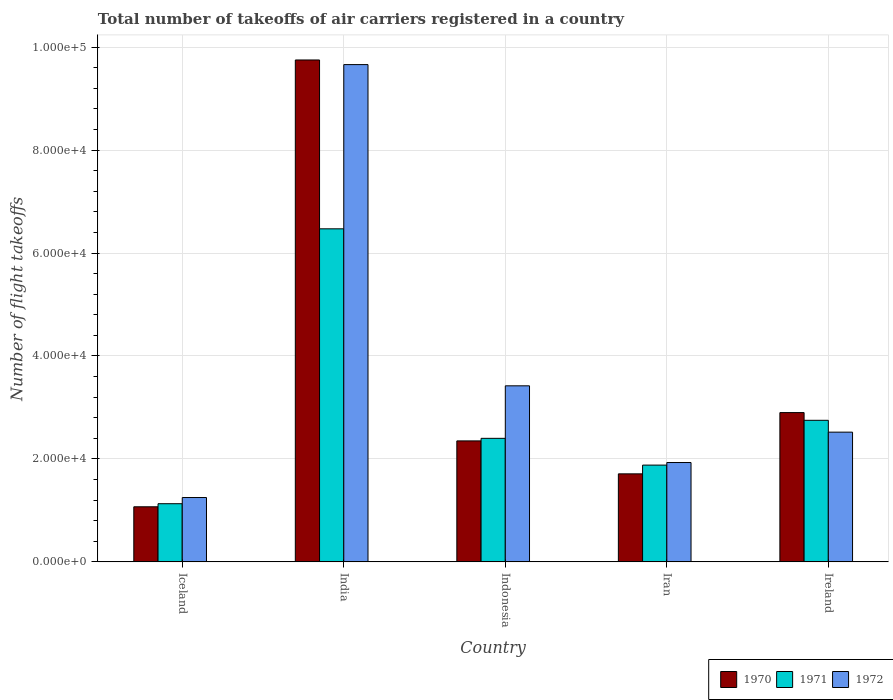How many different coloured bars are there?
Your answer should be very brief. 3. How many groups of bars are there?
Your response must be concise. 5. Are the number of bars per tick equal to the number of legend labels?
Give a very brief answer. Yes. Are the number of bars on each tick of the X-axis equal?
Give a very brief answer. Yes. How many bars are there on the 1st tick from the right?
Offer a very short reply. 3. What is the total number of flight takeoffs in 1970 in Indonesia?
Your answer should be very brief. 2.35e+04. Across all countries, what is the maximum total number of flight takeoffs in 1970?
Make the answer very short. 9.75e+04. Across all countries, what is the minimum total number of flight takeoffs in 1971?
Give a very brief answer. 1.13e+04. In which country was the total number of flight takeoffs in 1970 maximum?
Your response must be concise. India. In which country was the total number of flight takeoffs in 1972 minimum?
Give a very brief answer. Iceland. What is the total total number of flight takeoffs in 1972 in the graph?
Keep it short and to the point. 1.88e+05. What is the difference between the total number of flight takeoffs in 1972 in Iceland and that in India?
Make the answer very short. -8.41e+04. What is the difference between the total number of flight takeoffs in 1970 in Iceland and the total number of flight takeoffs in 1972 in Indonesia?
Give a very brief answer. -2.35e+04. What is the average total number of flight takeoffs in 1972 per country?
Your answer should be very brief. 3.76e+04. What is the difference between the total number of flight takeoffs of/in 1970 and total number of flight takeoffs of/in 1972 in Ireland?
Keep it short and to the point. 3800. What is the ratio of the total number of flight takeoffs in 1971 in Iceland to that in Iran?
Your response must be concise. 0.6. Is the total number of flight takeoffs in 1972 in India less than that in Iran?
Provide a succinct answer. No. Is the difference between the total number of flight takeoffs in 1970 in Iceland and Iran greater than the difference between the total number of flight takeoffs in 1972 in Iceland and Iran?
Provide a short and direct response. Yes. What is the difference between the highest and the second highest total number of flight takeoffs in 1970?
Your answer should be very brief. 5500. What is the difference between the highest and the lowest total number of flight takeoffs in 1972?
Provide a succinct answer. 8.41e+04. Is the sum of the total number of flight takeoffs in 1972 in India and Ireland greater than the maximum total number of flight takeoffs in 1971 across all countries?
Offer a terse response. Yes. What does the 2nd bar from the right in Iceland represents?
Make the answer very short. 1971. Is it the case that in every country, the sum of the total number of flight takeoffs in 1971 and total number of flight takeoffs in 1970 is greater than the total number of flight takeoffs in 1972?
Provide a short and direct response. Yes. How many countries are there in the graph?
Your answer should be very brief. 5. Does the graph contain any zero values?
Keep it short and to the point. No. Does the graph contain grids?
Your response must be concise. Yes. How are the legend labels stacked?
Provide a succinct answer. Horizontal. What is the title of the graph?
Ensure brevity in your answer.  Total number of takeoffs of air carriers registered in a country. Does "1979" appear as one of the legend labels in the graph?
Ensure brevity in your answer.  No. What is the label or title of the Y-axis?
Provide a succinct answer. Number of flight takeoffs. What is the Number of flight takeoffs in 1970 in Iceland?
Your answer should be compact. 1.07e+04. What is the Number of flight takeoffs in 1971 in Iceland?
Give a very brief answer. 1.13e+04. What is the Number of flight takeoffs of 1972 in Iceland?
Give a very brief answer. 1.25e+04. What is the Number of flight takeoffs in 1970 in India?
Offer a very short reply. 9.75e+04. What is the Number of flight takeoffs in 1971 in India?
Provide a short and direct response. 6.47e+04. What is the Number of flight takeoffs in 1972 in India?
Your response must be concise. 9.66e+04. What is the Number of flight takeoffs of 1970 in Indonesia?
Provide a succinct answer. 2.35e+04. What is the Number of flight takeoffs in 1971 in Indonesia?
Provide a succinct answer. 2.40e+04. What is the Number of flight takeoffs of 1972 in Indonesia?
Ensure brevity in your answer.  3.42e+04. What is the Number of flight takeoffs in 1970 in Iran?
Your response must be concise. 1.71e+04. What is the Number of flight takeoffs of 1971 in Iran?
Offer a very short reply. 1.88e+04. What is the Number of flight takeoffs of 1972 in Iran?
Offer a terse response. 1.93e+04. What is the Number of flight takeoffs in 1970 in Ireland?
Provide a short and direct response. 2.90e+04. What is the Number of flight takeoffs of 1971 in Ireland?
Ensure brevity in your answer.  2.75e+04. What is the Number of flight takeoffs of 1972 in Ireland?
Offer a terse response. 2.52e+04. Across all countries, what is the maximum Number of flight takeoffs in 1970?
Your response must be concise. 9.75e+04. Across all countries, what is the maximum Number of flight takeoffs of 1971?
Your response must be concise. 6.47e+04. Across all countries, what is the maximum Number of flight takeoffs in 1972?
Make the answer very short. 9.66e+04. Across all countries, what is the minimum Number of flight takeoffs of 1970?
Keep it short and to the point. 1.07e+04. Across all countries, what is the minimum Number of flight takeoffs of 1971?
Your answer should be very brief. 1.13e+04. Across all countries, what is the minimum Number of flight takeoffs in 1972?
Provide a succinct answer. 1.25e+04. What is the total Number of flight takeoffs of 1970 in the graph?
Offer a terse response. 1.78e+05. What is the total Number of flight takeoffs of 1971 in the graph?
Keep it short and to the point. 1.46e+05. What is the total Number of flight takeoffs of 1972 in the graph?
Your response must be concise. 1.88e+05. What is the difference between the Number of flight takeoffs of 1970 in Iceland and that in India?
Keep it short and to the point. -8.68e+04. What is the difference between the Number of flight takeoffs in 1971 in Iceland and that in India?
Make the answer very short. -5.34e+04. What is the difference between the Number of flight takeoffs in 1972 in Iceland and that in India?
Make the answer very short. -8.41e+04. What is the difference between the Number of flight takeoffs of 1970 in Iceland and that in Indonesia?
Provide a succinct answer. -1.28e+04. What is the difference between the Number of flight takeoffs of 1971 in Iceland and that in Indonesia?
Your answer should be very brief. -1.27e+04. What is the difference between the Number of flight takeoffs in 1972 in Iceland and that in Indonesia?
Ensure brevity in your answer.  -2.17e+04. What is the difference between the Number of flight takeoffs in 1970 in Iceland and that in Iran?
Ensure brevity in your answer.  -6400. What is the difference between the Number of flight takeoffs in 1971 in Iceland and that in Iran?
Offer a terse response. -7500. What is the difference between the Number of flight takeoffs of 1972 in Iceland and that in Iran?
Ensure brevity in your answer.  -6800. What is the difference between the Number of flight takeoffs in 1970 in Iceland and that in Ireland?
Offer a very short reply. -1.83e+04. What is the difference between the Number of flight takeoffs of 1971 in Iceland and that in Ireland?
Ensure brevity in your answer.  -1.62e+04. What is the difference between the Number of flight takeoffs in 1972 in Iceland and that in Ireland?
Your response must be concise. -1.27e+04. What is the difference between the Number of flight takeoffs of 1970 in India and that in Indonesia?
Ensure brevity in your answer.  7.40e+04. What is the difference between the Number of flight takeoffs of 1971 in India and that in Indonesia?
Offer a very short reply. 4.07e+04. What is the difference between the Number of flight takeoffs of 1972 in India and that in Indonesia?
Your answer should be very brief. 6.24e+04. What is the difference between the Number of flight takeoffs in 1970 in India and that in Iran?
Your answer should be compact. 8.04e+04. What is the difference between the Number of flight takeoffs in 1971 in India and that in Iran?
Offer a very short reply. 4.59e+04. What is the difference between the Number of flight takeoffs in 1972 in India and that in Iran?
Provide a succinct answer. 7.73e+04. What is the difference between the Number of flight takeoffs in 1970 in India and that in Ireland?
Provide a succinct answer. 6.85e+04. What is the difference between the Number of flight takeoffs of 1971 in India and that in Ireland?
Provide a succinct answer. 3.72e+04. What is the difference between the Number of flight takeoffs in 1972 in India and that in Ireland?
Ensure brevity in your answer.  7.14e+04. What is the difference between the Number of flight takeoffs of 1970 in Indonesia and that in Iran?
Offer a very short reply. 6400. What is the difference between the Number of flight takeoffs of 1971 in Indonesia and that in Iran?
Keep it short and to the point. 5200. What is the difference between the Number of flight takeoffs of 1972 in Indonesia and that in Iran?
Offer a very short reply. 1.49e+04. What is the difference between the Number of flight takeoffs in 1970 in Indonesia and that in Ireland?
Give a very brief answer. -5500. What is the difference between the Number of flight takeoffs of 1971 in Indonesia and that in Ireland?
Provide a short and direct response. -3500. What is the difference between the Number of flight takeoffs in 1972 in Indonesia and that in Ireland?
Provide a succinct answer. 9000. What is the difference between the Number of flight takeoffs in 1970 in Iran and that in Ireland?
Keep it short and to the point. -1.19e+04. What is the difference between the Number of flight takeoffs in 1971 in Iran and that in Ireland?
Ensure brevity in your answer.  -8700. What is the difference between the Number of flight takeoffs of 1972 in Iran and that in Ireland?
Make the answer very short. -5900. What is the difference between the Number of flight takeoffs in 1970 in Iceland and the Number of flight takeoffs in 1971 in India?
Your answer should be compact. -5.40e+04. What is the difference between the Number of flight takeoffs of 1970 in Iceland and the Number of flight takeoffs of 1972 in India?
Your response must be concise. -8.59e+04. What is the difference between the Number of flight takeoffs in 1971 in Iceland and the Number of flight takeoffs in 1972 in India?
Make the answer very short. -8.53e+04. What is the difference between the Number of flight takeoffs of 1970 in Iceland and the Number of flight takeoffs of 1971 in Indonesia?
Ensure brevity in your answer.  -1.33e+04. What is the difference between the Number of flight takeoffs in 1970 in Iceland and the Number of flight takeoffs in 1972 in Indonesia?
Provide a short and direct response. -2.35e+04. What is the difference between the Number of flight takeoffs of 1971 in Iceland and the Number of flight takeoffs of 1972 in Indonesia?
Ensure brevity in your answer.  -2.29e+04. What is the difference between the Number of flight takeoffs in 1970 in Iceland and the Number of flight takeoffs in 1971 in Iran?
Ensure brevity in your answer.  -8100. What is the difference between the Number of flight takeoffs in 1970 in Iceland and the Number of flight takeoffs in 1972 in Iran?
Ensure brevity in your answer.  -8600. What is the difference between the Number of flight takeoffs in 1971 in Iceland and the Number of flight takeoffs in 1972 in Iran?
Make the answer very short. -8000. What is the difference between the Number of flight takeoffs in 1970 in Iceland and the Number of flight takeoffs in 1971 in Ireland?
Make the answer very short. -1.68e+04. What is the difference between the Number of flight takeoffs of 1970 in Iceland and the Number of flight takeoffs of 1972 in Ireland?
Make the answer very short. -1.45e+04. What is the difference between the Number of flight takeoffs of 1971 in Iceland and the Number of flight takeoffs of 1972 in Ireland?
Offer a very short reply. -1.39e+04. What is the difference between the Number of flight takeoffs in 1970 in India and the Number of flight takeoffs in 1971 in Indonesia?
Ensure brevity in your answer.  7.35e+04. What is the difference between the Number of flight takeoffs in 1970 in India and the Number of flight takeoffs in 1972 in Indonesia?
Provide a short and direct response. 6.33e+04. What is the difference between the Number of flight takeoffs of 1971 in India and the Number of flight takeoffs of 1972 in Indonesia?
Give a very brief answer. 3.05e+04. What is the difference between the Number of flight takeoffs of 1970 in India and the Number of flight takeoffs of 1971 in Iran?
Your response must be concise. 7.87e+04. What is the difference between the Number of flight takeoffs of 1970 in India and the Number of flight takeoffs of 1972 in Iran?
Ensure brevity in your answer.  7.82e+04. What is the difference between the Number of flight takeoffs of 1971 in India and the Number of flight takeoffs of 1972 in Iran?
Your response must be concise. 4.54e+04. What is the difference between the Number of flight takeoffs in 1970 in India and the Number of flight takeoffs in 1972 in Ireland?
Provide a short and direct response. 7.23e+04. What is the difference between the Number of flight takeoffs in 1971 in India and the Number of flight takeoffs in 1972 in Ireland?
Your answer should be very brief. 3.95e+04. What is the difference between the Number of flight takeoffs in 1970 in Indonesia and the Number of flight takeoffs in 1971 in Iran?
Provide a short and direct response. 4700. What is the difference between the Number of flight takeoffs of 1970 in Indonesia and the Number of flight takeoffs of 1972 in Iran?
Your answer should be compact. 4200. What is the difference between the Number of flight takeoffs in 1971 in Indonesia and the Number of flight takeoffs in 1972 in Iran?
Provide a short and direct response. 4700. What is the difference between the Number of flight takeoffs in 1970 in Indonesia and the Number of flight takeoffs in 1971 in Ireland?
Ensure brevity in your answer.  -4000. What is the difference between the Number of flight takeoffs of 1970 in Indonesia and the Number of flight takeoffs of 1972 in Ireland?
Your answer should be very brief. -1700. What is the difference between the Number of flight takeoffs in 1971 in Indonesia and the Number of flight takeoffs in 1972 in Ireland?
Your answer should be very brief. -1200. What is the difference between the Number of flight takeoffs in 1970 in Iran and the Number of flight takeoffs in 1971 in Ireland?
Make the answer very short. -1.04e+04. What is the difference between the Number of flight takeoffs in 1970 in Iran and the Number of flight takeoffs in 1972 in Ireland?
Ensure brevity in your answer.  -8100. What is the difference between the Number of flight takeoffs in 1971 in Iran and the Number of flight takeoffs in 1972 in Ireland?
Offer a very short reply. -6400. What is the average Number of flight takeoffs of 1970 per country?
Keep it short and to the point. 3.56e+04. What is the average Number of flight takeoffs in 1971 per country?
Your response must be concise. 2.93e+04. What is the average Number of flight takeoffs in 1972 per country?
Offer a terse response. 3.76e+04. What is the difference between the Number of flight takeoffs of 1970 and Number of flight takeoffs of 1971 in Iceland?
Your answer should be compact. -600. What is the difference between the Number of flight takeoffs of 1970 and Number of flight takeoffs of 1972 in Iceland?
Ensure brevity in your answer.  -1800. What is the difference between the Number of flight takeoffs in 1971 and Number of flight takeoffs in 1972 in Iceland?
Ensure brevity in your answer.  -1200. What is the difference between the Number of flight takeoffs of 1970 and Number of flight takeoffs of 1971 in India?
Your response must be concise. 3.28e+04. What is the difference between the Number of flight takeoffs in 1970 and Number of flight takeoffs in 1972 in India?
Give a very brief answer. 900. What is the difference between the Number of flight takeoffs in 1971 and Number of flight takeoffs in 1972 in India?
Offer a terse response. -3.19e+04. What is the difference between the Number of flight takeoffs of 1970 and Number of flight takeoffs of 1971 in Indonesia?
Offer a very short reply. -500. What is the difference between the Number of flight takeoffs in 1970 and Number of flight takeoffs in 1972 in Indonesia?
Your answer should be compact. -1.07e+04. What is the difference between the Number of flight takeoffs in 1971 and Number of flight takeoffs in 1972 in Indonesia?
Ensure brevity in your answer.  -1.02e+04. What is the difference between the Number of flight takeoffs in 1970 and Number of flight takeoffs in 1971 in Iran?
Make the answer very short. -1700. What is the difference between the Number of flight takeoffs of 1970 and Number of flight takeoffs of 1972 in Iran?
Your answer should be very brief. -2200. What is the difference between the Number of flight takeoffs of 1971 and Number of flight takeoffs of 1972 in Iran?
Provide a succinct answer. -500. What is the difference between the Number of flight takeoffs of 1970 and Number of flight takeoffs of 1971 in Ireland?
Give a very brief answer. 1500. What is the difference between the Number of flight takeoffs of 1970 and Number of flight takeoffs of 1972 in Ireland?
Ensure brevity in your answer.  3800. What is the difference between the Number of flight takeoffs of 1971 and Number of flight takeoffs of 1972 in Ireland?
Provide a short and direct response. 2300. What is the ratio of the Number of flight takeoffs of 1970 in Iceland to that in India?
Make the answer very short. 0.11. What is the ratio of the Number of flight takeoffs of 1971 in Iceland to that in India?
Ensure brevity in your answer.  0.17. What is the ratio of the Number of flight takeoffs of 1972 in Iceland to that in India?
Provide a succinct answer. 0.13. What is the ratio of the Number of flight takeoffs in 1970 in Iceland to that in Indonesia?
Give a very brief answer. 0.46. What is the ratio of the Number of flight takeoffs of 1971 in Iceland to that in Indonesia?
Give a very brief answer. 0.47. What is the ratio of the Number of flight takeoffs of 1972 in Iceland to that in Indonesia?
Your answer should be very brief. 0.37. What is the ratio of the Number of flight takeoffs of 1970 in Iceland to that in Iran?
Keep it short and to the point. 0.63. What is the ratio of the Number of flight takeoffs of 1971 in Iceland to that in Iran?
Your response must be concise. 0.6. What is the ratio of the Number of flight takeoffs of 1972 in Iceland to that in Iran?
Provide a short and direct response. 0.65. What is the ratio of the Number of flight takeoffs of 1970 in Iceland to that in Ireland?
Keep it short and to the point. 0.37. What is the ratio of the Number of flight takeoffs of 1971 in Iceland to that in Ireland?
Provide a succinct answer. 0.41. What is the ratio of the Number of flight takeoffs in 1972 in Iceland to that in Ireland?
Make the answer very short. 0.5. What is the ratio of the Number of flight takeoffs in 1970 in India to that in Indonesia?
Give a very brief answer. 4.15. What is the ratio of the Number of flight takeoffs of 1971 in India to that in Indonesia?
Give a very brief answer. 2.7. What is the ratio of the Number of flight takeoffs of 1972 in India to that in Indonesia?
Make the answer very short. 2.82. What is the ratio of the Number of flight takeoffs in 1970 in India to that in Iran?
Give a very brief answer. 5.7. What is the ratio of the Number of flight takeoffs in 1971 in India to that in Iran?
Make the answer very short. 3.44. What is the ratio of the Number of flight takeoffs of 1972 in India to that in Iran?
Provide a succinct answer. 5.01. What is the ratio of the Number of flight takeoffs of 1970 in India to that in Ireland?
Make the answer very short. 3.36. What is the ratio of the Number of flight takeoffs in 1971 in India to that in Ireland?
Offer a very short reply. 2.35. What is the ratio of the Number of flight takeoffs of 1972 in India to that in Ireland?
Offer a very short reply. 3.83. What is the ratio of the Number of flight takeoffs of 1970 in Indonesia to that in Iran?
Ensure brevity in your answer.  1.37. What is the ratio of the Number of flight takeoffs in 1971 in Indonesia to that in Iran?
Keep it short and to the point. 1.28. What is the ratio of the Number of flight takeoffs of 1972 in Indonesia to that in Iran?
Your answer should be very brief. 1.77. What is the ratio of the Number of flight takeoffs in 1970 in Indonesia to that in Ireland?
Your answer should be very brief. 0.81. What is the ratio of the Number of flight takeoffs of 1971 in Indonesia to that in Ireland?
Give a very brief answer. 0.87. What is the ratio of the Number of flight takeoffs of 1972 in Indonesia to that in Ireland?
Keep it short and to the point. 1.36. What is the ratio of the Number of flight takeoffs in 1970 in Iran to that in Ireland?
Offer a terse response. 0.59. What is the ratio of the Number of flight takeoffs of 1971 in Iran to that in Ireland?
Your response must be concise. 0.68. What is the ratio of the Number of flight takeoffs of 1972 in Iran to that in Ireland?
Offer a very short reply. 0.77. What is the difference between the highest and the second highest Number of flight takeoffs in 1970?
Provide a short and direct response. 6.85e+04. What is the difference between the highest and the second highest Number of flight takeoffs of 1971?
Your answer should be very brief. 3.72e+04. What is the difference between the highest and the second highest Number of flight takeoffs in 1972?
Ensure brevity in your answer.  6.24e+04. What is the difference between the highest and the lowest Number of flight takeoffs in 1970?
Your response must be concise. 8.68e+04. What is the difference between the highest and the lowest Number of flight takeoffs in 1971?
Your answer should be compact. 5.34e+04. What is the difference between the highest and the lowest Number of flight takeoffs in 1972?
Your response must be concise. 8.41e+04. 